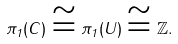<formula> <loc_0><loc_0><loc_500><loc_500>\pi _ { 1 } ( C ) \cong \pi _ { 1 } ( U ) \cong \mathbb { Z } .</formula> 